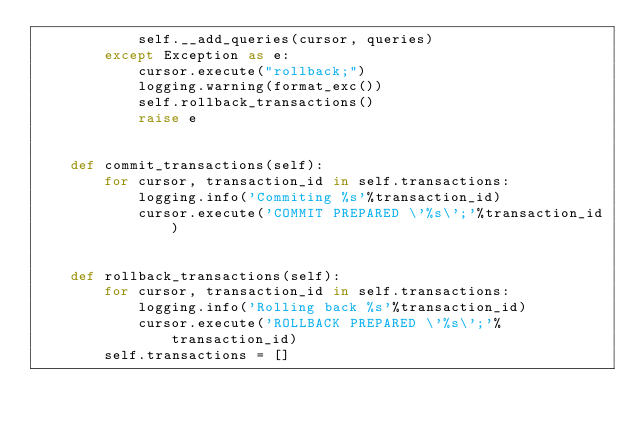Convert code to text. <code><loc_0><loc_0><loc_500><loc_500><_Python_>            self.__add_queries(cursor, queries)
        except Exception as e:
            cursor.execute("rollback;")
            logging.warning(format_exc())
            self.rollback_transactions()
            raise e


    def commit_transactions(self):
        for cursor, transaction_id in self.transactions:
            logging.info('Commiting %s'%transaction_id)
            cursor.execute('COMMIT PREPARED \'%s\';'%transaction_id)


    def rollback_transactions(self):
        for cursor, transaction_id in self.transactions:
            logging.info('Rolling back %s'%transaction_id)
            cursor.execute('ROLLBACK PREPARED \'%s\';'%transaction_id)
        self.transactions = []

</code> 